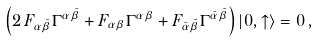Convert formula to latex. <formula><loc_0><loc_0><loc_500><loc_500>\left ( 2 \, F _ { \alpha \bar { \beta } } \Gamma ^ { \alpha \bar { \beta } } + F _ { \alpha \beta } \Gamma ^ { \alpha \beta } + F _ { \bar { \alpha } \bar { \beta } } \Gamma ^ { \bar { \alpha } \bar { \beta } } \right ) | 0 , \uparrow \rangle = 0 \, ,</formula> 